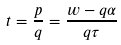Convert formula to latex. <formula><loc_0><loc_0><loc_500><loc_500>t = \frac { p } { q } = \frac { w - q \alpha } { q \tau }</formula> 